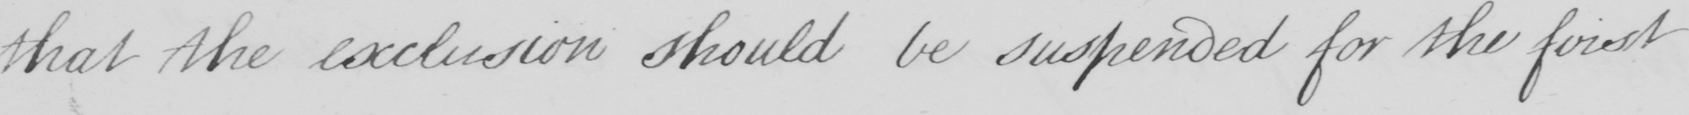Please provide the text content of this handwritten line. that the exclusion should be suspended for the first 